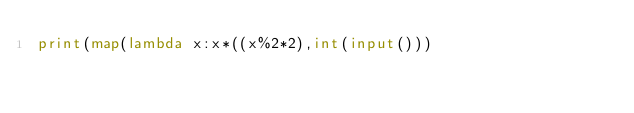Convert code to text. <code><loc_0><loc_0><loc_500><loc_500><_Python_>print(map(lambda x:x*((x%2*2),int(input()))</code> 